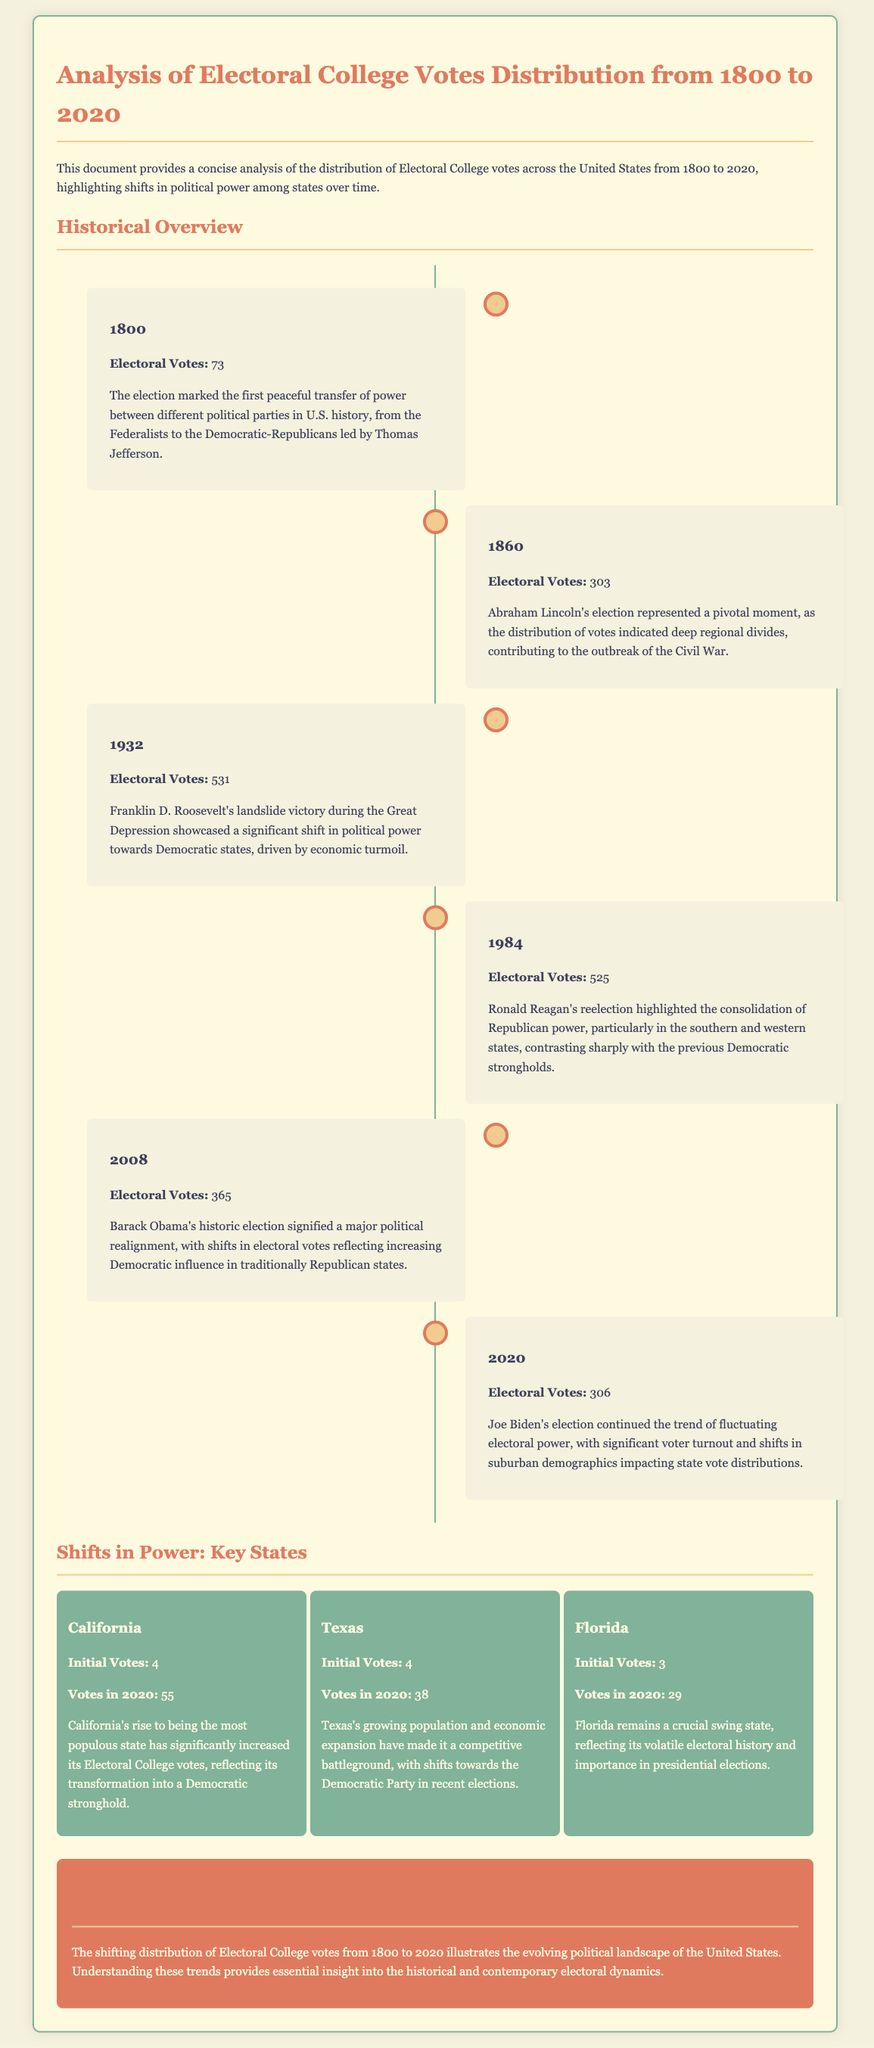What was the total number of Electoral Votes in 1800? The total number of Electoral Votes in 1800 was explicitly stated in the document.
Answer: 73 Which party experienced a shift in power during the 1932 election? The document highlights that Franklin D. Roosevelt's victory indicated a shift in political power towards Democratic states during the Great Depression.
Answer: Democratic How many electoral votes did Florida have in 2020? The document specifies the number of electoral votes for Florida in 2020.
Answer: 29 In what year did Abraham Lincoln win the election with 303 electoral votes? The document cites the year associated with Lincoln’s election and its electoral vote count.
Answer: 1860 What was the initial number of electoral votes for California? The document provides the historical electoral votes for California at the start.
Answer: 4 What significant event did the election of 1800 represent in U.S. history? The document describes the election of 1800 as the first peaceful transfer of power between different political parties.
Answer: Peaceful transfer of power Which two states have seen a political shift towards the Democratic Party? The document discusses the shifts in electoral power towards the Democratic Party concerning specific states, particularly Texas and California.
Answer: Texas, California What is the content theme of the document? The theme of the document focuses on the analysis of electoral college votes distribution over a specified time period in U.S. history.
Answer: Electoral College Votes Distribution Analysis What does the timeline in the document mainly depict? The timeline provides a chronological overview of key presidential elections and their electoral vote distributions, showcasing historical shifts.
Answer: Key presidential elections 